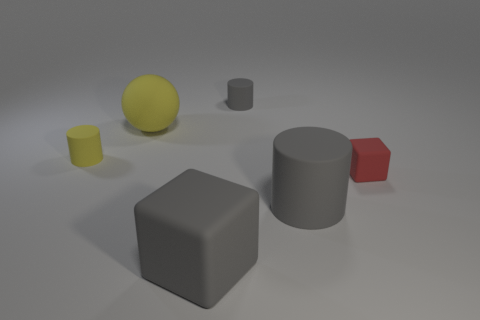What is the color of the other matte cylinder that is the same size as the yellow rubber cylinder?
Offer a terse response. Gray. Is the size of the yellow rubber ball the same as the gray rubber cube?
Your response must be concise. Yes. How many small cylinders are left of the big block?
Your response must be concise. 1. What number of things are either big rubber balls behind the tiny red block or large green metallic blocks?
Give a very brief answer. 1. Are there more large things that are in front of the tiny red rubber cube than small yellow matte objects right of the large matte ball?
Your answer should be very brief. Yes. There is a matte cylinder that is the same color as the ball; what size is it?
Give a very brief answer. Small. Do the red matte block and the gray cylinder in front of the yellow sphere have the same size?
Give a very brief answer. No. What number of blocks are large things or rubber objects?
Give a very brief answer. 2. There is a yellow cylinder that is the same material as the small gray object; what is its size?
Your answer should be very brief. Small. Do the cylinder behind the large yellow ball and the gray rubber cylinder in front of the tiny red rubber object have the same size?
Offer a very short reply. No. 